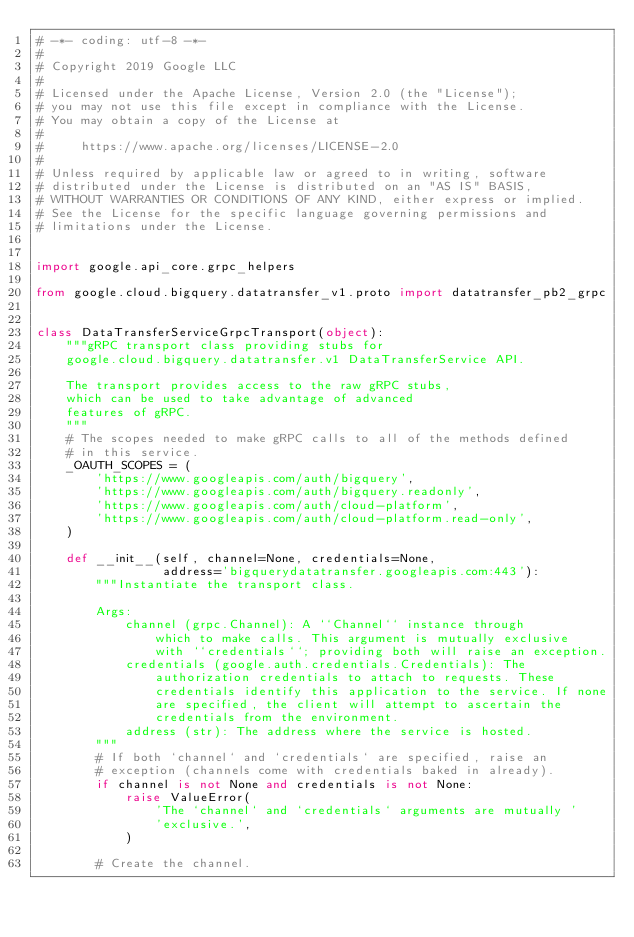Convert code to text. <code><loc_0><loc_0><loc_500><loc_500><_Python_># -*- coding: utf-8 -*-
#
# Copyright 2019 Google LLC
#
# Licensed under the Apache License, Version 2.0 (the "License");
# you may not use this file except in compliance with the License.
# You may obtain a copy of the License at
#
#     https://www.apache.org/licenses/LICENSE-2.0
#
# Unless required by applicable law or agreed to in writing, software
# distributed under the License is distributed on an "AS IS" BASIS,
# WITHOUT WARRANTIES OR CONDITIONS OF ANY KIND, either express or implied.
# See the License for the specific language governing permissions and
# limitations under the License.


import google.api_core.grpc_helpers

from google.cloud.bigquery.datatransfer_v1.proto import datatransfer_pb2_grpc


class DataTransferServiceGrpcTransport(object):
    """gRPC transport class providing stubs for
    google.cloud.bigquery.datatransfer.v1 DataTransferService API.

    The transport provides access to the raw gRPC stubs,
    which can be used to take advantage of advanced
    features of gRPC.
    """
    # The scopes needed to make gRPC calls to all of the methods defined
    # in this service.
    _OAUTH_SCOPES = (
        'https://www.googleapis.com/auth/bigquery',
        'https://www.googleapis.com/auth/bigquery.readonly',
        'https://www.googleapis.com/auth/cloud-platform',
        'https://www.googleapis.com/auth/cloud-platform.read-only',
    )

    def __init__(self, channel=None, credentials=None,
                 address='bigquerydatatransfer.googleapis.com:443'):
        """Instantiate the transport class.

        Args:
            channel (grpc.Channel): A ``Channel`` instance through
                which to make calls. This argument is mutually exclusive
                with ``credentials``; providing both will raise an exception.
            credentials (google.auth.credentials.Credentials): The
                authorization credentials to attach to requests. These
                credentials identify this application to the service. If none
                are specified, the client will attempt to ascertain the
                credentials from the environment.
            address (str): The address where the service is hosted.
        """
        # If both `channel` and `credentials` are specified, raise an
        # exception (channels come with credentials baked in already).
        if channel is not None and credentials is not None:
            raise ValueError(
                'The `channel` and `credentials` arguments are mutually '
                'exclusive.',
            )

        # Create the channel.</code> 